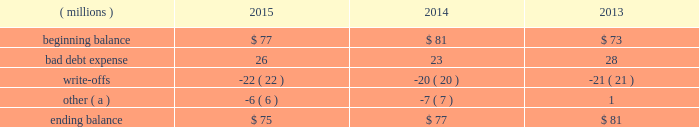Concentration of credit risk credit risk represents the accounting loss that would be recognized at the reporting date if counterparties failed to perform as contracted .
The company believes the likelihood of incurring material losses due to concentration of credit risk is remote .
The principal financial instruments subject to credit risk are as follows : cash and cash equivalents - the company maintains cash deposits with major banks , which from time to time may exceed insured limits .
The possibility of loss related to financial condition of major banks has been deemed minimal .
Additionally , the company 2019s investment policy limits exposure to concentrations of credit risk and changes in market conditions .
Accounts receivable - a large number of customers in diverse industries and geographies , as well as the practice of establishing reasonable credit lines , limits credit risk .
Based on historical trends and experiences , the allowance for doubtful accounts is adequate to cover potential credit risk losses .
Foreign currency and interest rate contracts and derivatives - exposure to credit risk is limited by internal policies and active monitoring of counterparty risks .
In addition , the company uses a diversified group of major international banks and financial institutions as counterparties .
The company does not anticipate nonperformance by any of these counterparties .
Cash and cash equivalents cash equivalents include highly-liquid investments with a maturity of three months or less when purchased .
Accounts receivable and allowance for doubtful accounts accounts receivable are carried at their face amounts less an allowance for doubtful accounts .
Accounts receivable are recorded at the invoiced amount and generally do not bear interest .
The company estimates the balance of allowance for doubtful accounts by analyzing accounts receivable balances by age and applying historical write-off and collection trend rates .
The company 2019s estimates include separately providing for customer balances based on specific circumstances and credit conditions , and when it is deemed probable that the balance is uncollectible .
Account balances are charged off against the allowance when it is determined the receivable will not be recovered .
The company 2019s allowance for doubtful accounts balance also includes an allowance for the expected return of products shipped and credits related to pricing or quantities shipped of $ 15 million as of december 31 , 2015 and 2014 and $ 14 million as of december 31 , 2013 .
Returns and credit activity is recorded directly to sales .
The table summarizes the activity in the allowance for doubtful accounts: .
( a ) other amounts are primarily the effects of changes in currency translations and the impact of allowance for returns and credits .
Inventory valuations inventories are valued at the lower of cost or market .
Certain u.s .
Inventory costs are determined on a last-in , first-out ( lifo ) basis .
Lifo inventories represented 39% ( 39 % ) and 37% ( 37 % ) of consolidated inventories as of december 31 , 2015 and 2014 , respectively .
Lifo inventories include certain legacy nalco u.s .
Inventory acquired at fair value as part of the nalco merger .
All other inventory costs are determined using either the average cost or first-in , first-out ( fifo ) methods .
Inventory values at fifo , as shown in note 5 , approximate replacement during the fourth quarter of 2015 , the company improved estimates related to its inventory reserves and product costing , resulting in a net pre-tax charge of approximately $ 6 million .
Separately , the actions resulted in charge of $ 20.6 million related to inventory reserve calculations , partially offset by a gain of $ 14.5 million related to the capitalization of certain cost components into inventory .
Both of these items are reflected in note 3. .
What is the average percent of lifo inventories as a percent of consolidated inventories as of december 31 , 2015 and 2014? 
Computations: ((39 + 37) / 2)
Answer: 38.0. 